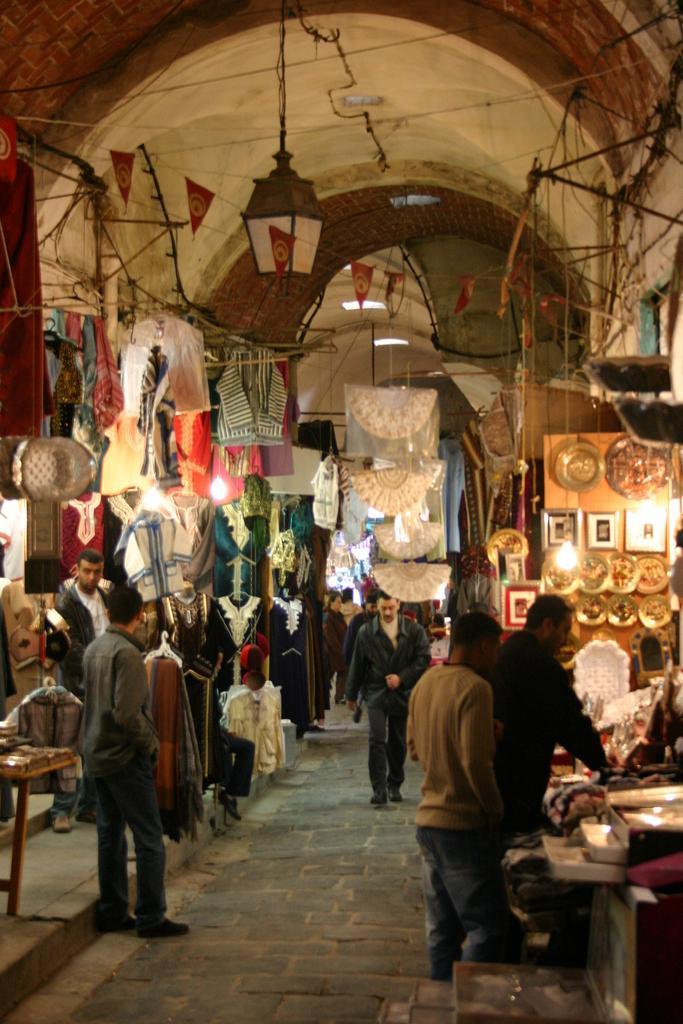Can you describe this image briefly? At the bottom of the image few people are standing and walking. Behind them we can see some clothes and lights. At the top of the image we can see ceiling and banners. 